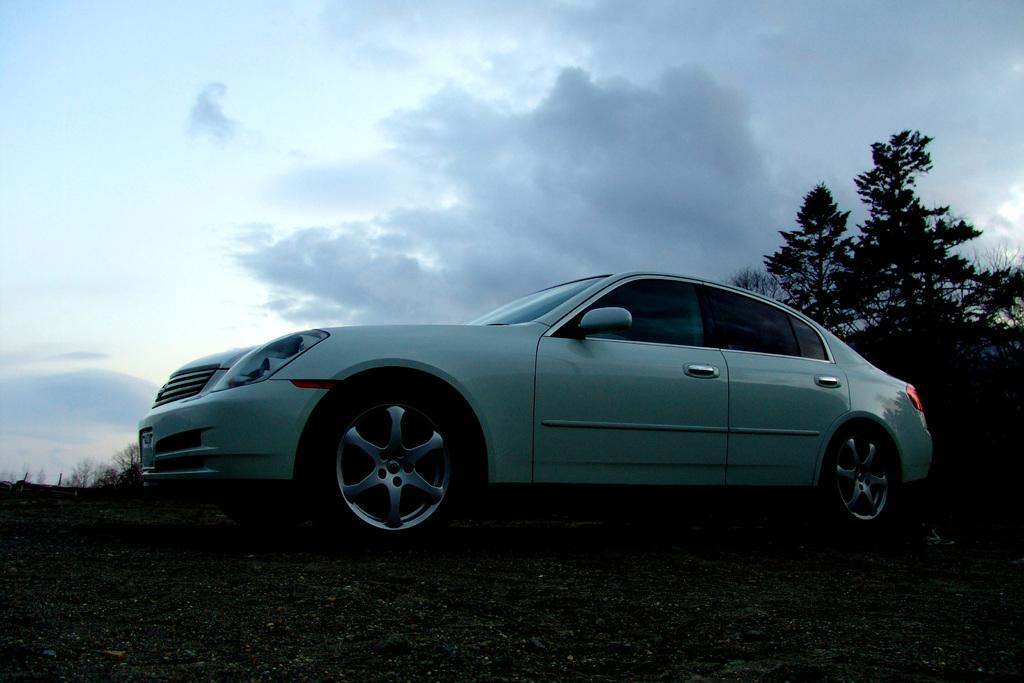What is located on the ground in the image? There is a vehicle on the ground in the image. What type of natural environment can be seen in the image? There are trees visible in the image. What is visible in the background of the image? The sky is visible in the background of the image. What can be observed in the sky? Clouds are present in the sky. What color is the seat visible in the image? There is no seat present in the image. Can you describe the kicking motion of the person in the image? There is no person or kicking motion present in the image. 